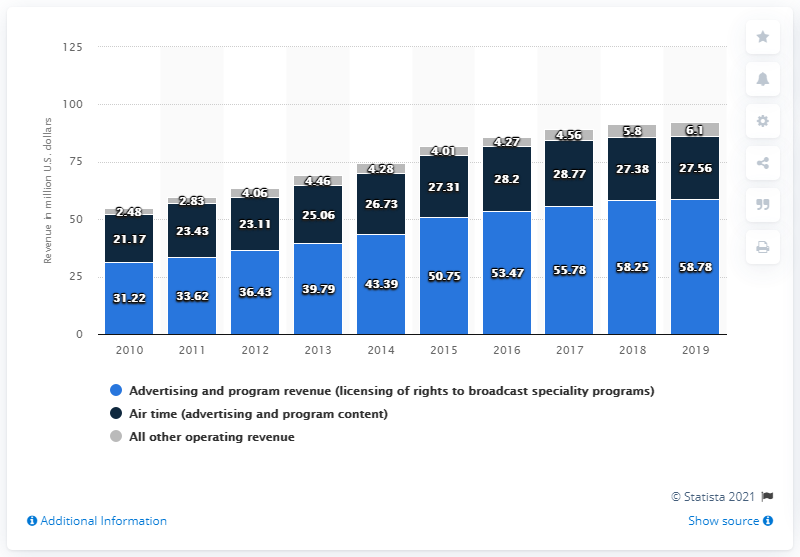What does the bar with the lightest color represent in this chart? The bar with the lightest color in the chart represents 'Air time (advertising and program content).' This category is one segment of the revenue, along with 'Advertising and program revenue' and 'All other operating revenue'. And how does the air time revenue compare to the other categories? The air time revenue is the smallest category when compared to the other two. Over the years displayed, it ranges from about 23.11 million to 28.73 million U.S. dollars, while the other categories consistently generate higher revenue. 